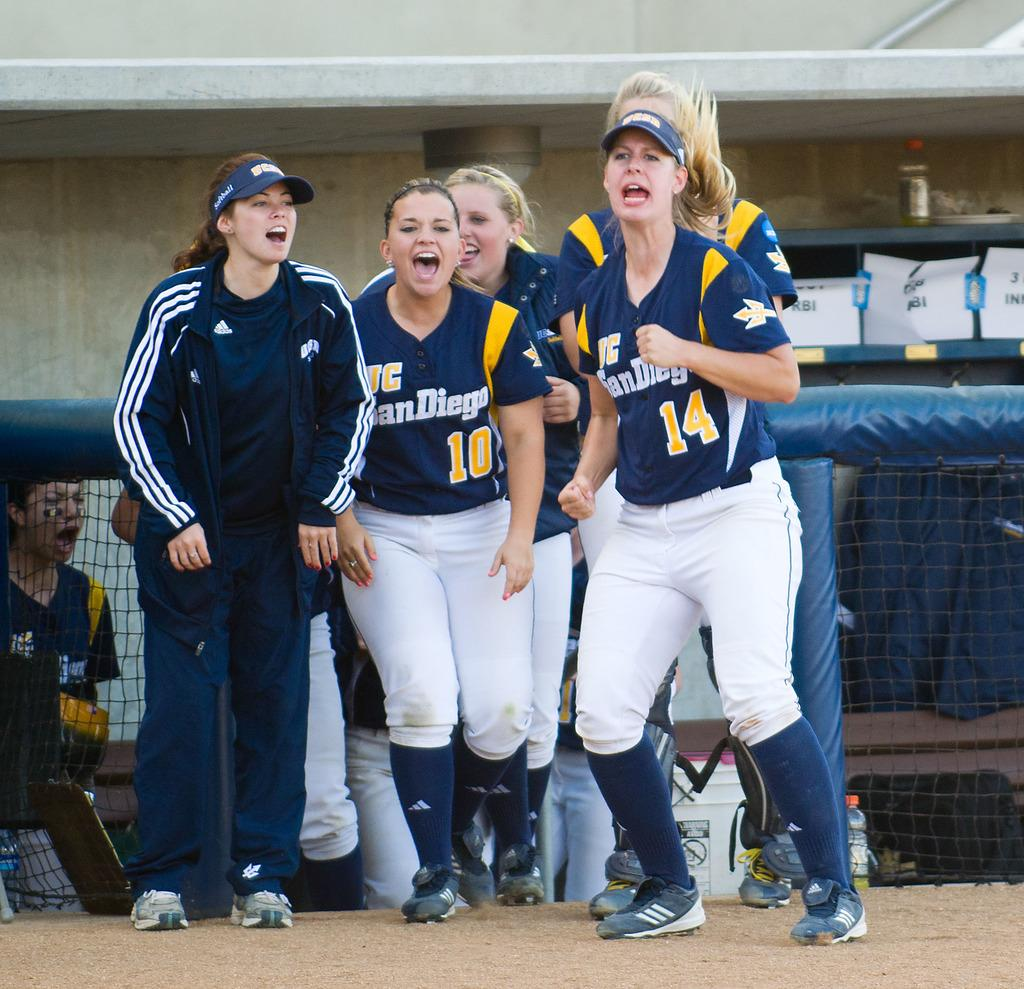Provide a one-sentence caption for the provided image. The women play for the San Diego softball team. 